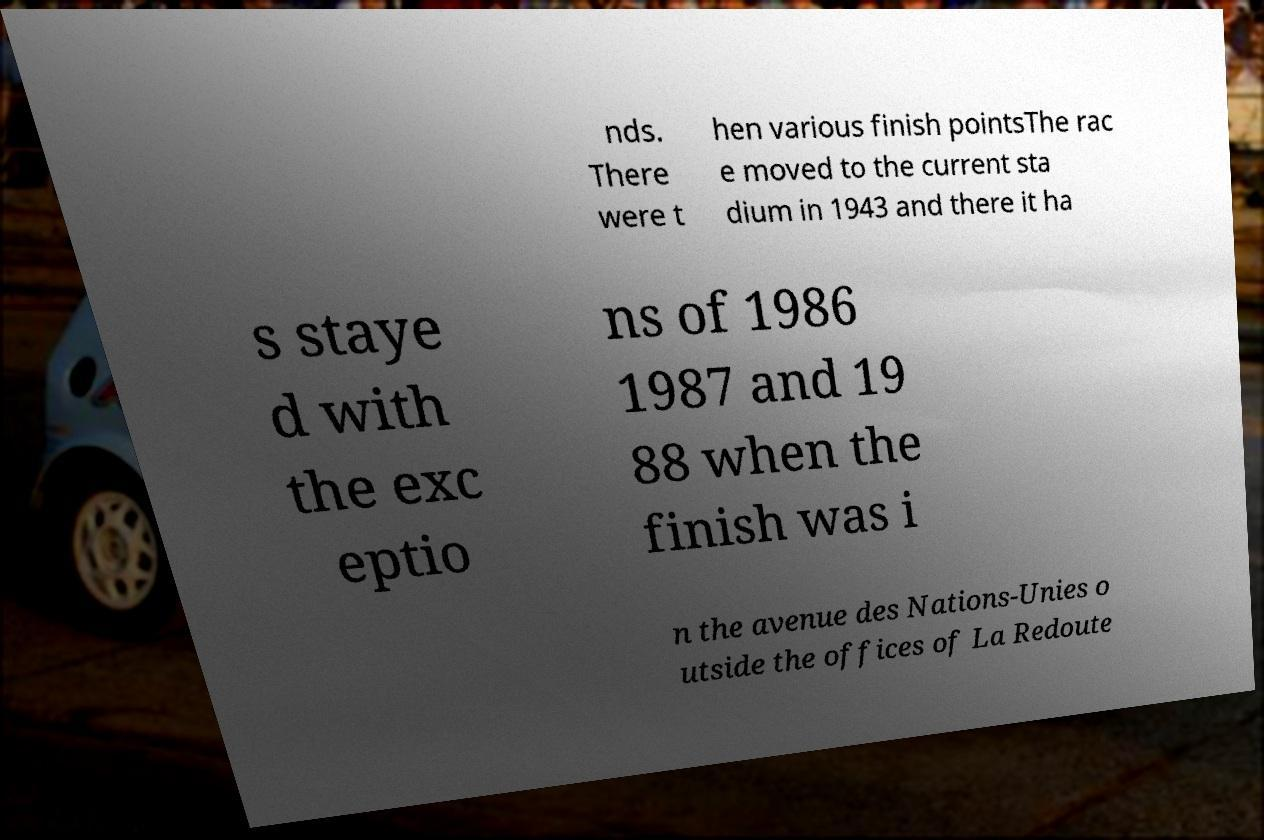Could you assist in decoding the text presented in this image and type it out clearly? nds. There were t hen various finish pointsThe rac e moved to the current sta dium in 1943 and there it ha s staye d with the exc eptio ns of 1986 1987 and 19 88 when the finish was i n the avenue des Nations-Unies o utside the offices of La Redoute 